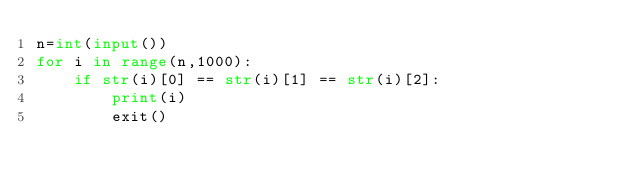Convert code to text. <code><loc_0><loc_0><loc_500><loc_500><_Python_>n=int(input())
for i in range(n,1000):
    if str(i)[0] == str(i)[1] == str(i)[2]:
        print(i)
        exit()</code> 